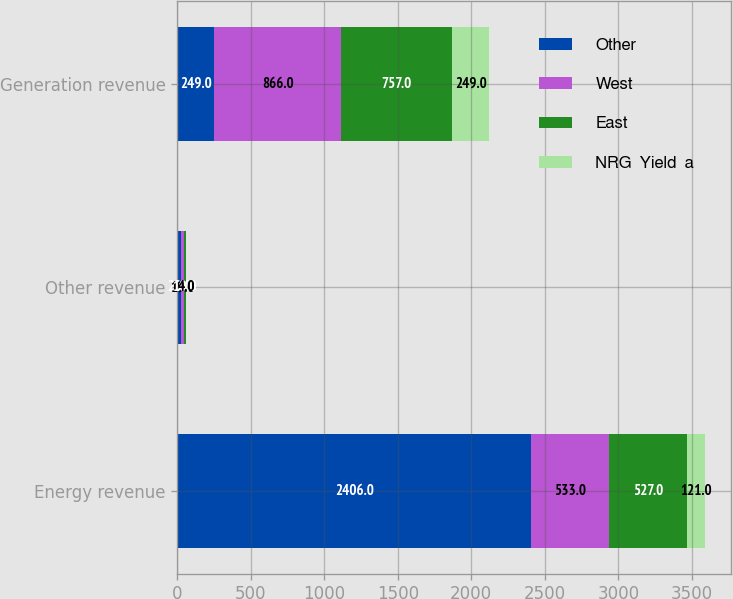Convert chart to OTSL. <chart><loc_0><loc_0><loc_500><loc_500><stacked_bar_chart><ecel><fcel>Energy revenue<fcel>Other revenue<fcel>Generation revenue<nl><fcel>Other<fcel>2406<fcel>28<fcel>249<nl><fcel>West<fcel>533<fcel>19<fcel>866<nl><fcel>East<fcel>527<fcel>10<fcel>757<nl><fcel>NRG  Yield  a<fcel>121<fcel>4<fcel>249<nl></chart> 